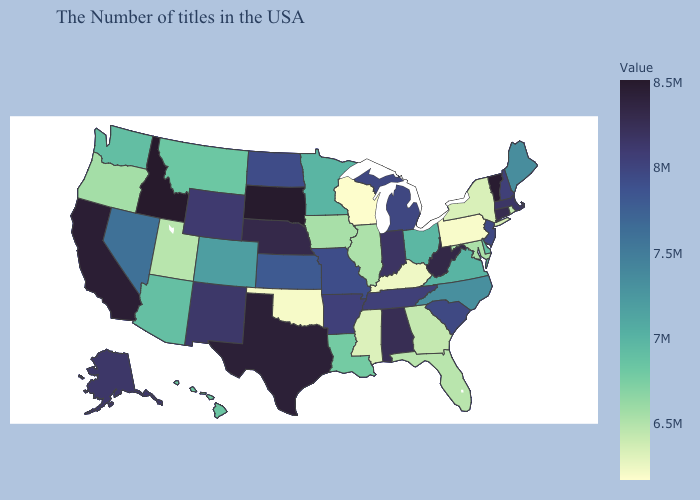Among the states that border Washington , does Idaho have the lowest value?
Write a very short answer. No. Among the states that border Michigan , does Indiana have the highest value?
Short answer required. Yes. Among the states that border Iowa , does Missouri have the highest value?
Answer briefly. No. Does Idaho have the highest value in the USA?
Concise answer only. Yes. Does the map have missing data?
Give a very brief answer. No. Which states have the lowest value in the West?
Write a very short answer. Utah. 